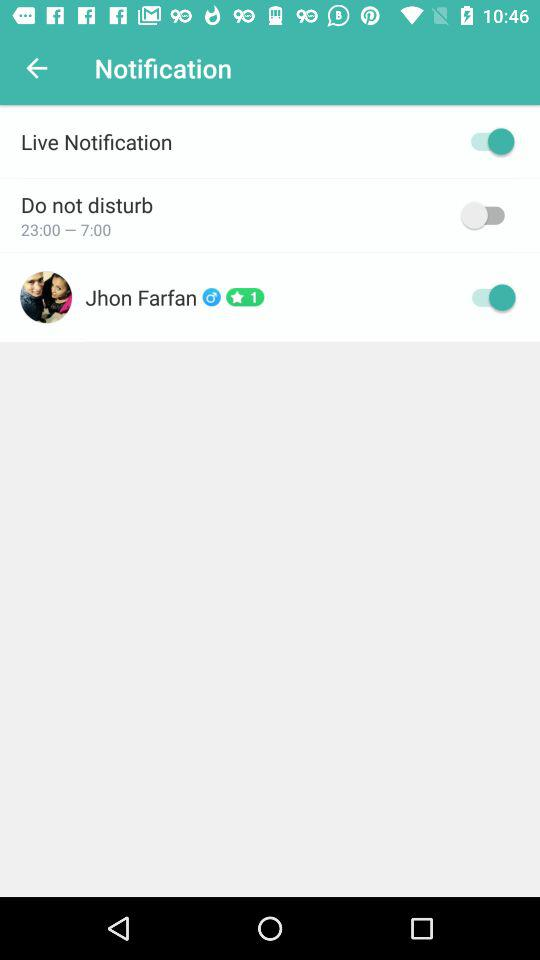What are the timings set for do not disturb? The timings are 23:00–7:00. 